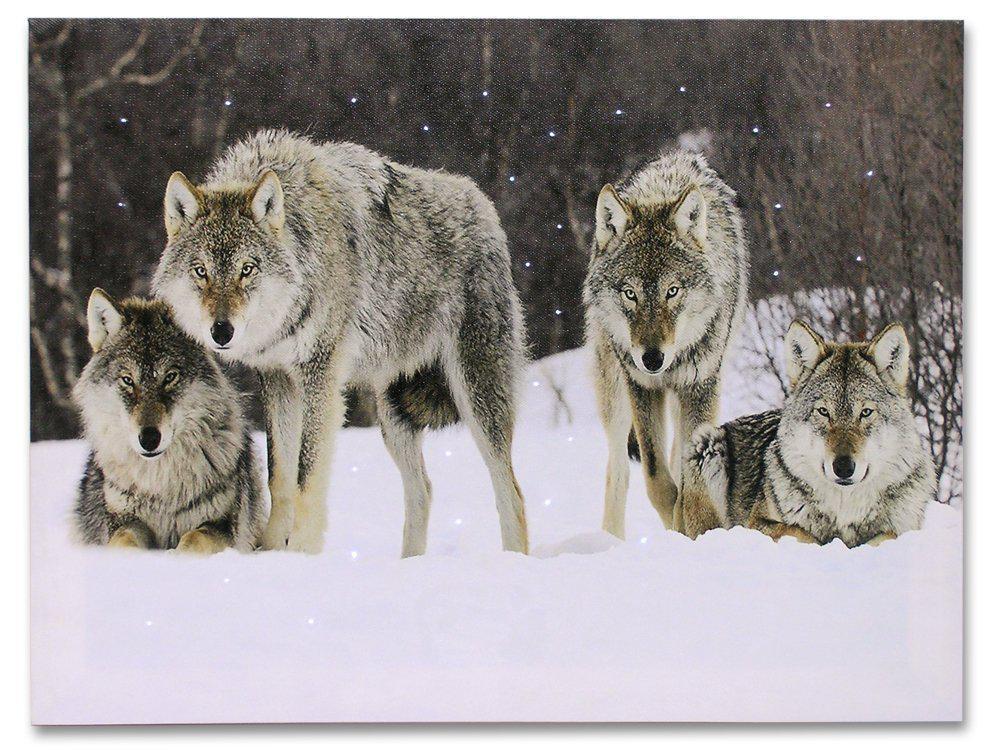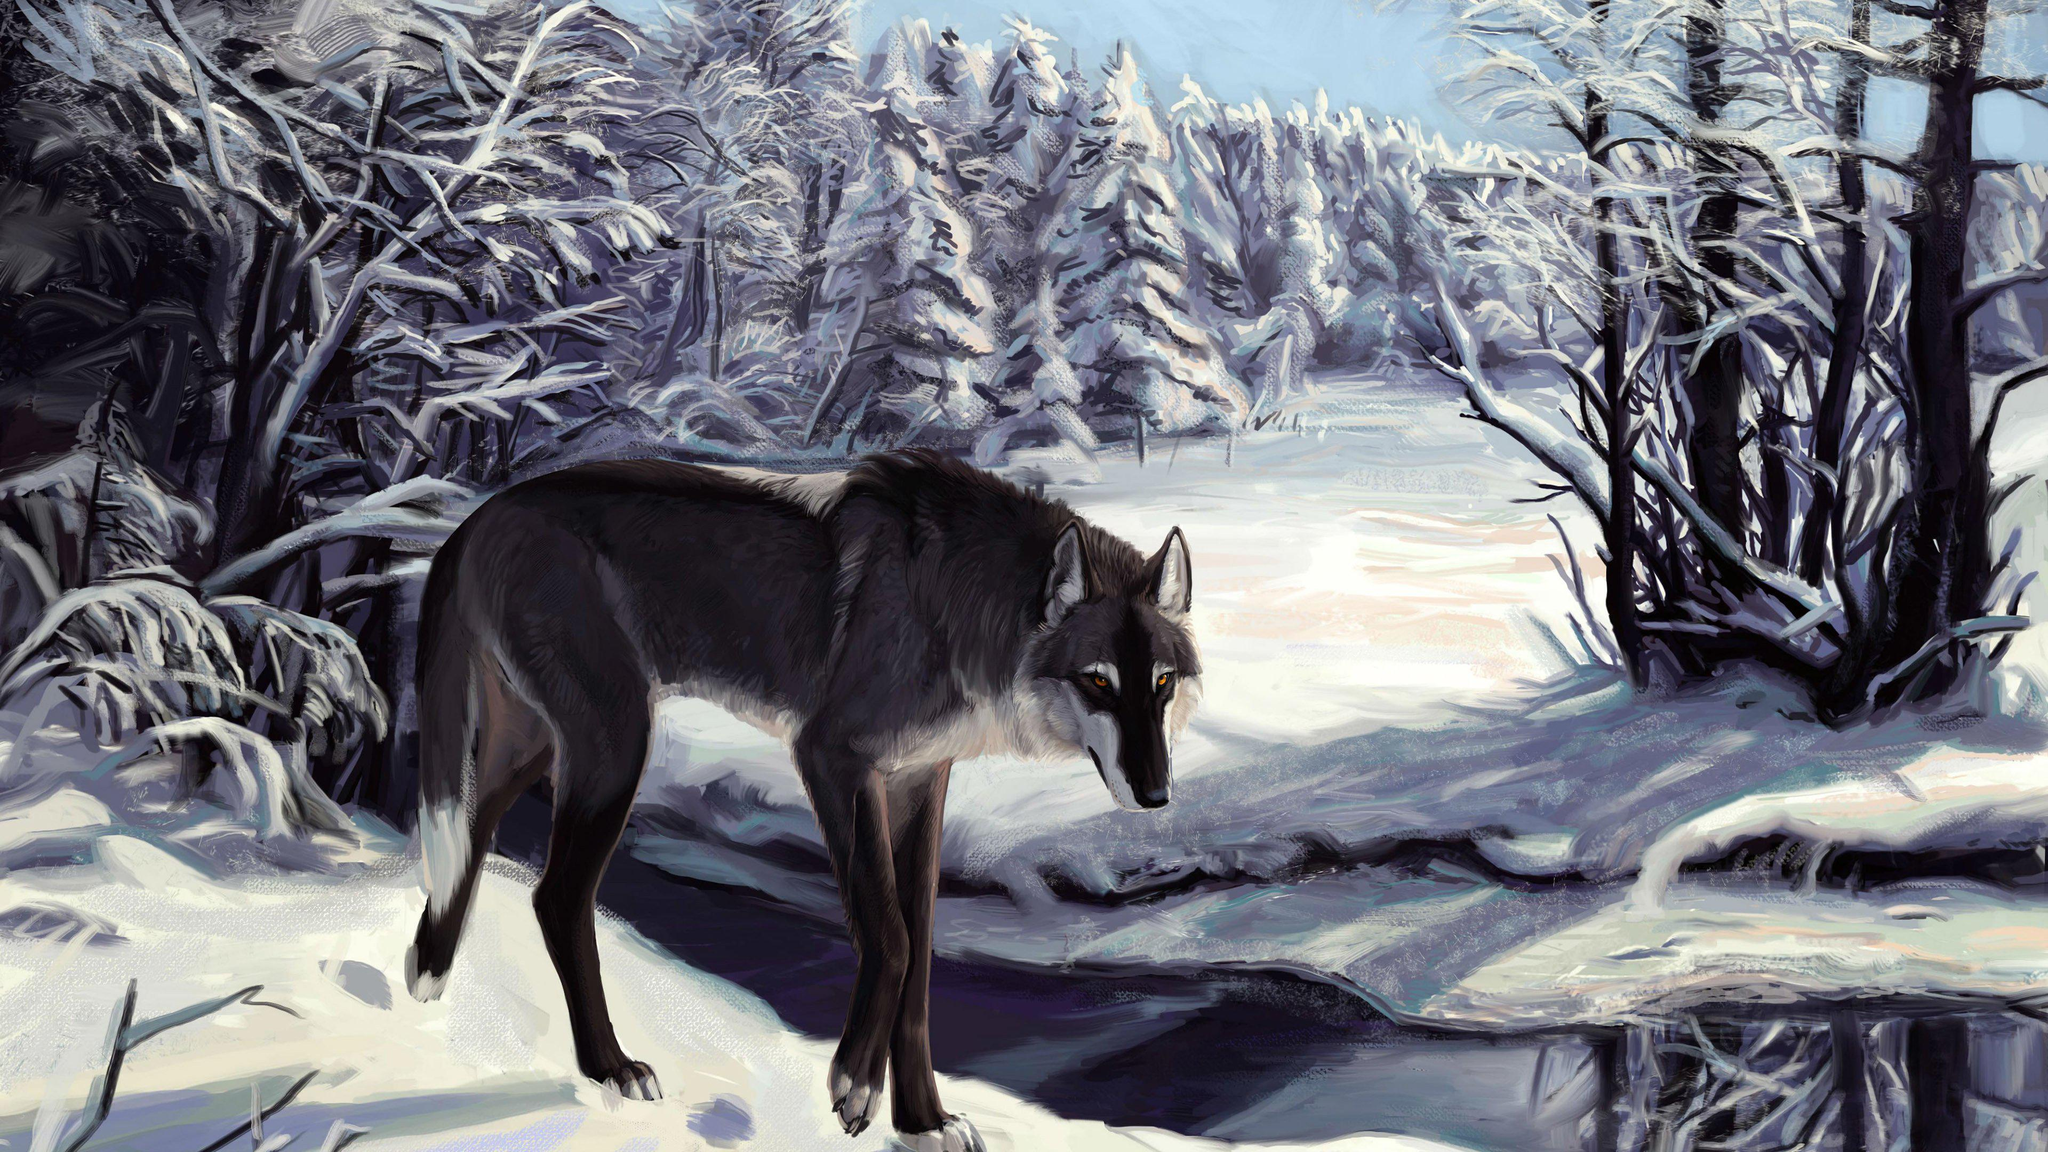The first image is the image on the left, the second image is the image on the right. Evaluate the accuracy of this statement regarding the images: "One image in the set contains exactly 3 wolves, in a snowy setting with at least one tree in the background.". Is it true? Answer yes or no. No. The first image is the image on the left, the second image is the image on the right. Examine the images to the left and right. Is the description "An image shows only two wolves in a snowy scene." accurate? Answer yes or no. No. 